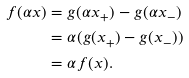<formula> <loc_0><loc_0><loc_500><loc_500>f ( \alpha x ) & = g ( \alpha x _ { + } ) - g ( \alpha x _ { - } ) \\ & = \alpha ( g ( x _ { + } ) - g ( x _ { - } ) ) \\ & = \alpha f ( x ) .</formula> 